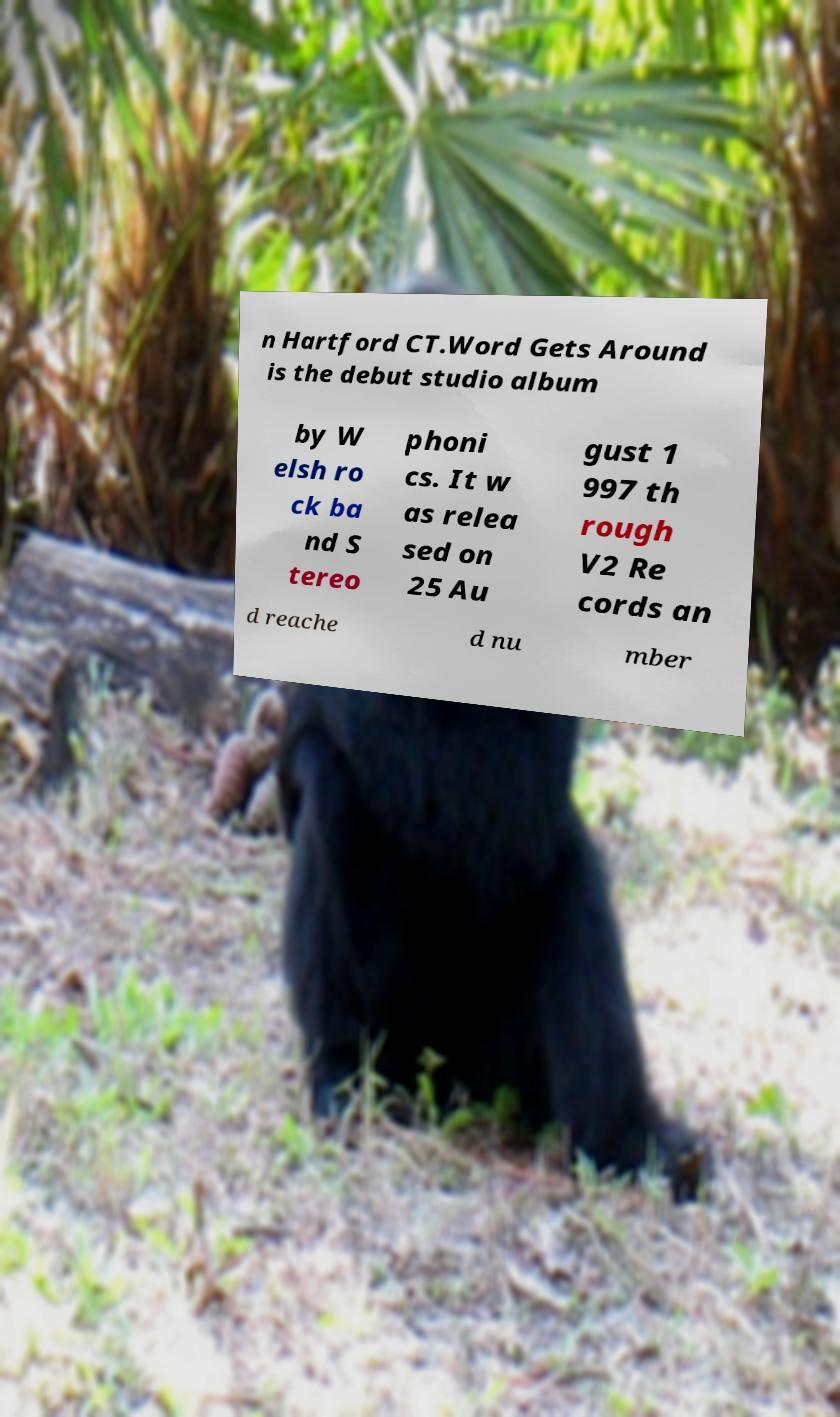I need the written content from this picture converted into text. Can you do that? n Hartford CT.Word Gets Around is the debut studio album by W elsh ro ck ba nd S tereo phoni cs. It w as relea sed on 25 Au gust 1 997 th rough V2 Re cords an d reache d nu mber 